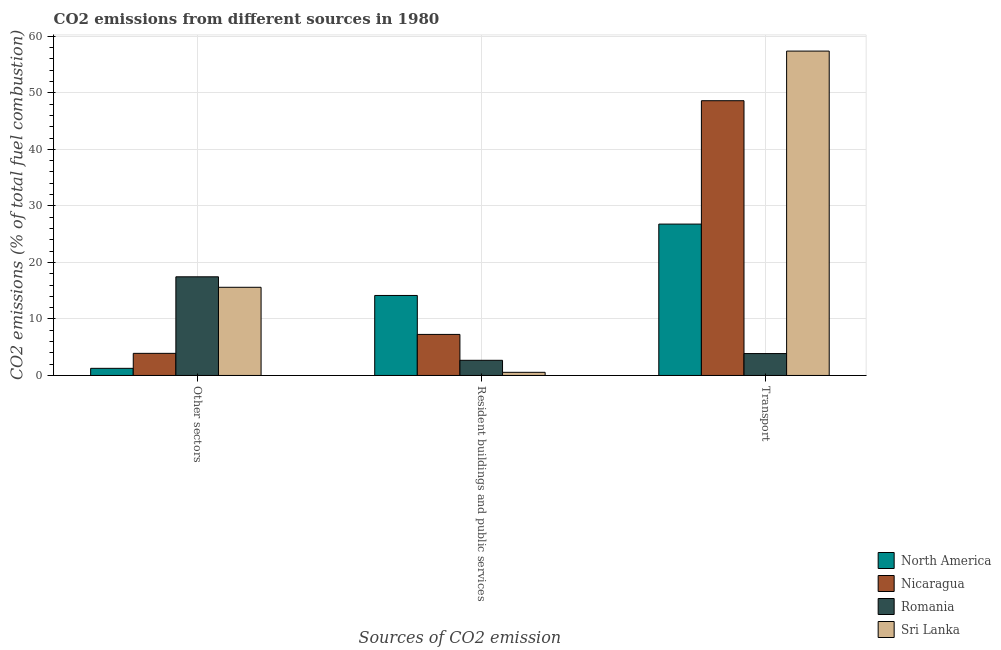How many groups of bars are there?
Offer a very short reply. 3. How many bars are there on the 2nd tick from the left?
Give a very brief answer. 4. How many bars are there on the 2nd tick from the right?
Your answer should be very brief. 4. What is the label of the 1st group of bars from the left?
Your answer should be very brief. Other sectors. What is the percentage of co2 emissions from resident buildings and public services in Nicaragua?
Provide a short and direct response. 7.26. Across all countries, what is the maximum percentage of co2 emissions from other sectors?
Your response must be concise. 17.45. Across all countries, what is the minimum percentage of co2 emissions from resident buildings and public services?
Your answer should be compact. 0.56. In which country was the percentage of co2 emissions from other sectors maximum?
Keep it short and to the point. Romania. What is the total percentage of co2 emissions from other sectors in the graph?
Your answer should be very brief. 38.22. What is the difference between the percentage of co2 emissions from other sectors in Nicaragua and that in Sri Lanka?
Your answer should be compact. -11.69. What is the difference between the percentage of co2 emissions from other sectors in North America and the percentage of co2 emissions from resident buildings and public services in Nicaragua?
Provide a short and direct response. -6. What is the average percentage of co2 emissions from resident buildings and public services per country?
Provide a succinct answer. 6.16. What is the difference between the percentage of co2 emissions from other sectors and percentage of co2 emissions from transport in North America?
Offer a terse response. -25.52. What is the ratio of the percentage of co2 emissions from transport in Romania to that in North America?
Keep it short and to the point. 0.14. Is the difference between the percentage of co2 emissions from transport in Romania and Sri Lanka greater than the difference between the percentage of co2 emissions from other sectors in Romania and Sri Lanka?
Provide a short and direct response. No. What is the difference between the highest and the second highest percentage of co2 emissions from transport?
Your response must be concise. 8.78. What is the difference between the highest and the lowest percentage of co2 emissions from transport?
Provide a succinct answer. 53.51. What does the 3rd bar from the left in Resident buildings and public services represents?
Keep it short and to the point. Romania. What does the 4th bar from the right in Resident buildings and public services represents?
Your answer should be compact. North America. How many bars are there?
Your answer should be very brief. 12. How many countries are there in the graph?
Ensure brevity in your answer.  4. What is the difference between two consecutive major ticks on the Y-axis?
Keep it short and to the point. 10. Does the graph contain any zero values?
Keep it short and to the point. No. Does the graph contain grids?
Your answer should be compact. Yes. How are the legend labels stacked?
Ensure brevity in your answer.  Vertical. What is the title of the graph?
Offer a very short reply. CO2 emissions from different sources in 1980. Does "Bermuda" appear as one of the legend labels in the graph?
Provide a succinct answer. No. What is the label or title of the X-axis?
Your answer should be very brief. Sources of CO2 emission. What is the label or title of the Y-axis?
Offer a terse response. CO2 emissions (% of total fuel combustion). What is the CO2 emissions (% of total fuel combustion) of North America in Other sectors?
Your answer should be compact. 1.26. What is the CO2 emissions (% of total fuel combustion) in Nicaragua in Other sectors?
Keep it short and to the point. 3.91. What is the CO2 emissions (% of total fuel combustion) of Romania in Other sectors?
Ensure brevity in your answer.  17.45. What is the CO2 emissions (% of total fuel combustion) of Sri Lanka in Other sectors?
Ensure brevity in your answer.  15.6. What is the CO2 emissions (% of total fuel combustion) in North America in Resident buildings and public services?
Your response must be concise. 14.15. What is the CO2 emissions (% of total fuel combustion) of Nicaragua in Resident buildings and public services?
Your answer should be very brief. 7.26. What is the CO2 emissions (% of total fuel combustion) in Romania in Resident buildings and public services?
Offer a very short reply. 2.68. What is the CO2 emissions (% of total fuel combustion) of Sri Lanka in Resident buildings and public services?
Your answer should be compact. 0.56. What is the CO2 emissions (% of total fuel combustion) in North America in Transport?
Ensure brevity in your answer.  26.78. What is the CO2 emissions (% of total fuel combustion) of Nicaragua in Transport?
Your answer should be compact. 48.6. What is the CO2 emissions (% of total fuel combustion) of Romania in Transport?
Offer a very short reply. 3.87. What is the CO2 emissions (% of total fuel combustion) of Sri Lanka in Transport?
Offer a terse response. 57.38. Across all Sources of CO2 emission, what is the maximum CO2 emissions (% of total fuel combustion) of North America?
Give a very brief answer. 26.78. Across all Sources of CO2 emission, what is the maximum CO2 emissions (% of total fuel combustion) in Nicaragua?
Offer a terse response. 48.6. Across all Sources of CO2 emission, what is the maximum CO2 emissions (% of total fuel combustion) of Romania?
Your answer should be very brief. 17.45. Across all Sources of CO2 emission, what is the maximum CO2 emissions (% of total fuel combustion) in Sri Lanka?
Give a very brief answer. 57.38. Across all Sources of CO2 emission, what is the minimum CO2 emissions (% of total fuel combustion) of North America?
Your answer should be compact. 1.26. Across all Sources of CO2 emission, what is the minimum CO2 emissions (% of total fuel combustion) of Nicaragua?
Your answer should be compact. 3.91. Across all Sources of CO2 emission, what is the minimum CO2 emissions (% of total fuel combustion) of Romania?
Provide a succinct answer. 2.68. Across all Sources of CO2 emission, what is the minimum CO2 emissions (% of total fuel combustion) in Sri Lanka?
Your answer should be compact. 0.56. What is the total CO2 emissions (% of total fuel combustion) of North America in the graph?
Your answer should be compact. 42.19. What is the total CO2 emissions (% of total fuel combustion) of Nicaragua in the graph?
Make the answer very short. 59.78. What is the total CO2 emissions (% of total fuel combustion) in Romania in the graph?
Make the answer very short. 24.01. What is the total CO2 emissions (% of total fuel combustion) of Sri Lanka in the graph?
Offer a very short reply. 73.54. What is the difference between the CO2 emissions (% of total fuel combustion) in North America in Other sectors and that in Resident buildings and public services?
Provide a short and direct response. -12.89. What is the difference between the CO2 emissions (% of total fuel combustion) of Nicaragua in Other sectors and that in Resident buildings and public services?
Keep it short and to the point. -3.35. What is the difference between the CO2 emissions (% of total fuel combustion) in Romania in Other sectors and that in Resident buildings and public services?
Provide a short and direct response. 14.77. What is the difference between the CO2 emissions (% of total fuel combustion) of Sri Lanka in Other sectors and that in Resident buildings and public services?
Keep it short and to the point. 15.04. What is the difference between the CO2 emissions (% of total fuel combustion) of North America in Other sectors and that in Transport?
Give a very brief answer. -25.52. What is the difference between the CO2 emissions (% of total fuel combustion) of Nicaragua in Other sectors and that in Transport?
Offer a terse response. -44.69. What is the difference between the CO2 emissions (% of total fuel combustion) of Romania in Other sectors and that in Transport?
Your answer should be very brief. 13.58. What is the difference between the CO2 emissions (% of total fuel combustion) in Sri Lanka in Other sectors and that in Transport?
Give a very brief answer. -41.78. What is the difference between the CO2 emissions (% of total fuel combustion) in North America in Resident buildings and public services and that in Transport?
Provide a succinct answer. -12.63. What is the difference between the CO2 emissions (% of total fuel combustion) of Nicaragua in Resident buildings and public services and that in Transport?
Give a very brief answer. -41.34. What is the difference between the CO2 emissions (% of total fuel combustion) of Romania in Resident buildings and public services and that in Transport?
Make the answer very short. -1.19. What is the difference between the CO2 emissions (% of total fuel combustion) of Sri Lanka in Resident buildings and public services and that in Transport?
Ensure brevity in your answer.  -56.82. What is the difference between the CO2 emissions (% of total fuel combustion) of North America in Other sectors and the CO2 emissions (% of total fuel combustion) of Nicaragua in Resident buildings and public services?
Keep it short and to the point. -6. What is the difference between the CO2 emissions (% of total fuel combustion) in North America in Other sectors and the CO2 emissions (% of total fuel combustion) in Romania in Resident buildings and public services?
Your answer should be compact. -1.42. What is the difference between the CO2 emissions (% of total fuel combustion) in North America in Other sectors and the CO2 emissions (% of total fuel combustion) in Sri Lanka in Resident buildings and public services?
Keep it short and to the point. 0.7. What is the difference between the CO2 emissions (% of total fuel combustion) in Nicaragua in Other sectors and the CO2 emissions (% of total fuel combustion) in Romania in Resident buildings and public services?
Give a very brief answer. 1.23. What is the difference between the CO2 emissions (% of total fuel combustion) of Nicaragua in Other sectors and the CO2 emissions (% of total fuel combustion) of Sri Lanka in Resident buildings and public services?
Keep it short and to the point. 3.35. What is the difference between the CO2 emissions (% of total fuel combustion) of Romania in Other sectors and the CO2 emissions (% of total fuel combustion) of Sri Lanka in Resident buildings and public services?
Provide a succinct answer. 16.9. What is the difference between the CO2 emissions (% of total fuel combustion) in North America in Other sectors and the CO2 emissions (% of total fuel combustion) in Nicaragua in Transport?
Ensure brevity in your answer.  -47.34. What is the difference between the CO2 emissions (% of total fuel combustion) of North America in Other sectors and the CO2 emissions (% of total fuel combustion) of Romania in Transport?
Make the answer very short. -2.61. What is the difference between the CO2 emissions (% of total fuel combustion) of North America in Other sectors and the CO2 emissions (% of total fuel combustion) of Sri Lanka in Transport?
Provide a succinct answer. -56.12. What is the difference between the CO2 emissions (% of total fuel combustion) of Nicaragua in Other sectors and the CO2 emissions (% of total fuel combustion) of Romania in Transport?
Offer a very short reply. 0.04. What is the difference between the CO2 emissions (% of total fuel combustion) of Nicaragua in Other sectors and the CO2 emissions (% of total fuel combustion) of Sri Lanka in Transport?
Offer a terse response. -53.47. What is the difference between the CO2 emissions (% of total fuel combustion) of Romania in Other sectors and the CO2 emissions (% of total fuel combustion) of Sri Lanka in Transport?
Your response must be concise. -39.93. What is the difference between the CO2 emissions (% of total fuel combustion) of North America in Resident buildings and public services and the CO2 emissions (% of total fuel combustion) of Nicaragua in Transport?
Ensure brevity in your answer.  -34.45. What is the difference between the CO2 emissions (% of total fuel combustion) in North America in Resident buildings and public services and the CO2 emissions (% of total fuel combustion) in Romania in Transport?
Offer a terse response. 10.28. What is the difference between the CO2 emissions (% of total fuel combustion) in North America in Resident buildings and public services and the CO2 emissions (% of total fuel combustion) in Sri Lanka in Transport?
Provide a succinct answer. -43.23. What is the difference between the CO2 emissions (% of total fuel combustion) of Nicaragua in Resident buildings and public services and the CO2 emissions (% of total fuel combustion) of Romania in Transport?
Keep it short and to the point. 3.39. What is the difference between the CO2 emissions (% of total fuel combustion) in Nicaragua in Resident buildings and public services and the CO2 emissions (% of total fuel combustion) in Sri Lanka in Transport?
Ensure brevity in your answer.  -50.12. What is the difference between the CO2 emissions (% of total fuel combustion) of Romania in Resident buildings and public services and the CO2 emissions (% of total fuel combustion) of Sri Lanka in Transport?
Your answer should be very brief. -54.7. What is the average CO2 emissions (% of total fuel combustion) of North America per Sources of CO2 emission?
Ensure brevity in your answer.  14.06. What is the average CO2 emissions (% of total fuel combustion) in Nicaragua per Sources of CO2 emission?
Ensure brevity in your answer.  19.93. What is the average CO2 emissions (% of total fuel combustion) in Romania per Sources of CO2 emission?
Keep it short and to the point. 8. What is the average CO2 emissions (% of total fuel combustion) of Sri Lanka per Sources of CO2 emission?
Your response must be concise. 24.51. What is the difference between the CO2 emissions (% of total fuel combustion) in North America and CO2 emissions (% of total fuel combustion) in Nicaragua in Other sectors?
Give a very brief answer. -2.65. What is the difference between the CO2 emissions (% of total fuel combustion) in North America and CO2 emissions (% of total fuel combustion) in Romania in Other sectors?
Offer a terse response. -16.19. What is the difference between the CO2 emissions (% of total fuel combustion) of North America and CO2 emissions (% of total fuel combustion) of Sri Lanka in Other sectors?
Your response must be concise. -14.34. What is the difference between the CO2 emissions (% of total fuel combustion) of Nicaragua and CO2 emissions (% of total fuel combustion) of Romania in Other sectors?
Your answer should be very brief. -13.54. What is the difference between the CO2 emissions (% of total fuel combustion) of Nicaragua and CO2 emissions (% of total fuel combustion) of Sri Lanka in Other sectors?
Give a very brief answer. -11.69. What is the difference between the CO2 emissions (% of total fuel combustion) of Romania and CO2 emissions (% of total fuel combustion) of Sri Lanka in Other sectors?
Your response must be concise. 1.85. What is the difference between the CO2 emissions (% of total fuel combustion) in North America and CO2 emissions (% of total fuel combustion) in Nicaragua in Resident buildings and public services?
Provide a succinct answer. 6.89. What is the difference between the CO2 emissions (% of total fuel combustion) of North America and CO2 emissions (% of total fuel combustion) of Romania in Resident buildings and public services?
Offer a very short reply. 11.47. What is the difference between the CO2 emissions (% of total fuel combustion) in North America and CO2 emissions (% of total fuel combustion) in Sri Lanka in Resident buildings and public services?
Offer a terse response. 13.6. What is the difference between the CO2 emissions (% of total fuel combustion) of Nicaragua and CO2 emissions (% of total fuel combustion) of Romania in Resident buildings and public services?
Offer a very short reply. 4.58. What is the difference between the CO2 emissions (% of total fuel combustion) of Nicaragua and CO2 emissions (% of total fuel combustion) of Sri Lanka in Resident buildings and public services?
Make the answer very short. 6.71. What is the difference between the CO2 emissions (% of total fuel combustion) in Romania and CO2 emissions (% of total fuel combustion) in Sri Lanka in Resident buildings and public services?
Keep it short and to the point. 2.12. What is the difference between the CO2 emissions (% of total fuel combustion) of North America and CO2 emissions (% of total fuel combustion) of Nicaragua in Transport?
Provide a short and direct response. -21.82. What is the difference between the CO2 emissions (% of total fuel combustion) of North America and CO2 emissions (% of total fuel combustion) of Romania in Transport?
Your answer should be very brief. 22.91. What is the difference between the CO2 emissions (% of total fuel combustion) in North America and CO2 emissions (% of total fuel combustion) in Sri Lanka in Transport?
Your answer should be compact. -30.6. What is the difference between the CO2 emissions (% of total fuel combustion) of Nicaragua and CO2 emissions (% of total fuel combustion) of Romania in Transport?
Provide a short and direct response. 44.73. What is the difference between the CO2 emissions (% of total fuel combustion) in Nicaragua and CO2 emissions (% of total fuel combustion) in Sri Lanka in Transport?
Offer a very short reply. -8.78. What is the difference between the CO2 emissions (% of total fuel combustion) of Romania and CO2 emissions (% of total fuel combustion) of Sri Lanka in Transport?
Provide a succinct answer. -53.51. What is the ratio of the CO2 emissions (% of total fuel combustion) of North America in Other sectors to that in Resident buildings and public services?
Keep it short and to the point. 0.09. What is the ratio of the CO2 emissions (% of total fuel combustion) of Nicaragua in Other sectors to that in Resident buildings and public services?
Provide a short and direct response. 0.54. What is the ratio of the CO2 emissions (% of total fuel combustion) of Romania in Other sectors to that in Resident buildings and public services?
Provide a succinct answer. 6.51. What is the ratio of the CO2 emissions (% of total fuel combustion) of North America in Other sectors to that in Transport?
Offer a terse response. 0.05. What is the ratio of the CO2 emissions (% of total fuel combustion) of Nicaragua in Other sectors to that in Transport?
Keep it short and to the point. 0.08. What is the ratio of the CO2 emissions (% of total fuel combustion) in Romania in Other sectors to that in Transport?
Give a very brief answer. 4.51. What is the ratio of the CO2 emissions (% of total fuel combustion) of Sri Lanka in Other sectors to that in Transport?
Offer a very short reply. 0.27. What is the ratio of the CO2 emissions (% of total fuel combustion) in North America in Resident buildings and public services to that in Transport?
Your answer should be very brief. 0.53. What is the ratio of the CO2 emissions (% of total fuel combustion) in Nicaragua in Resident buildings and public services to that in Transport?
Your answer should be compact. 0.15. What is the ratio of the CO2 emissions (% of total fuel combustion) of Romania in Resident buildings and public services to that in Transport?
Offer a terse response. 0.69. What is the ratio of the CO2 emissions (% of total fuel combustion) in Sri Lanka in Resident buildings and public services to that in Transport?
Offer a very short reply. 0.01. What is the difference between the highest and the second highest CO2 emissions (% of total fuel combustion) of North America?
Your answer should be compact. 12.63. What is the difference between the highest and the second highest CO2 emissions (% of total fuel combustion) in Nicaragua?
Give a very brief answer. 41.34. What is the difference between the highest and the second highest CO2 emissions (% of total fuel combustion) of Romania?
Provide a succinct answer. 13.58. What is the difference between the highest and the second highest CO2 emissions (% of total fuel combustion) of Sri Lanka?
Your answer should be very brief. 41.78. What is the difference between the highest and the lowest CO2 emissions (% of total fuel combustion) of North America?
Provide a succinct answer. 25.52. What is the difference between the highest and the lowest CO2 emissions (% of total fuel combustion) of Nicaragua?
Give a very brief answer. 44.69. What is the difference between the highest and the lowest CO2 emissions (% of total fuel combustion) of Romania?
Your answer should be compact. 14.77. What is the difference between the highest and the lowest CO2 emissions (% of total fuel combustion) of Sri Lanka?
Provide a short and direct response. 56.82. 